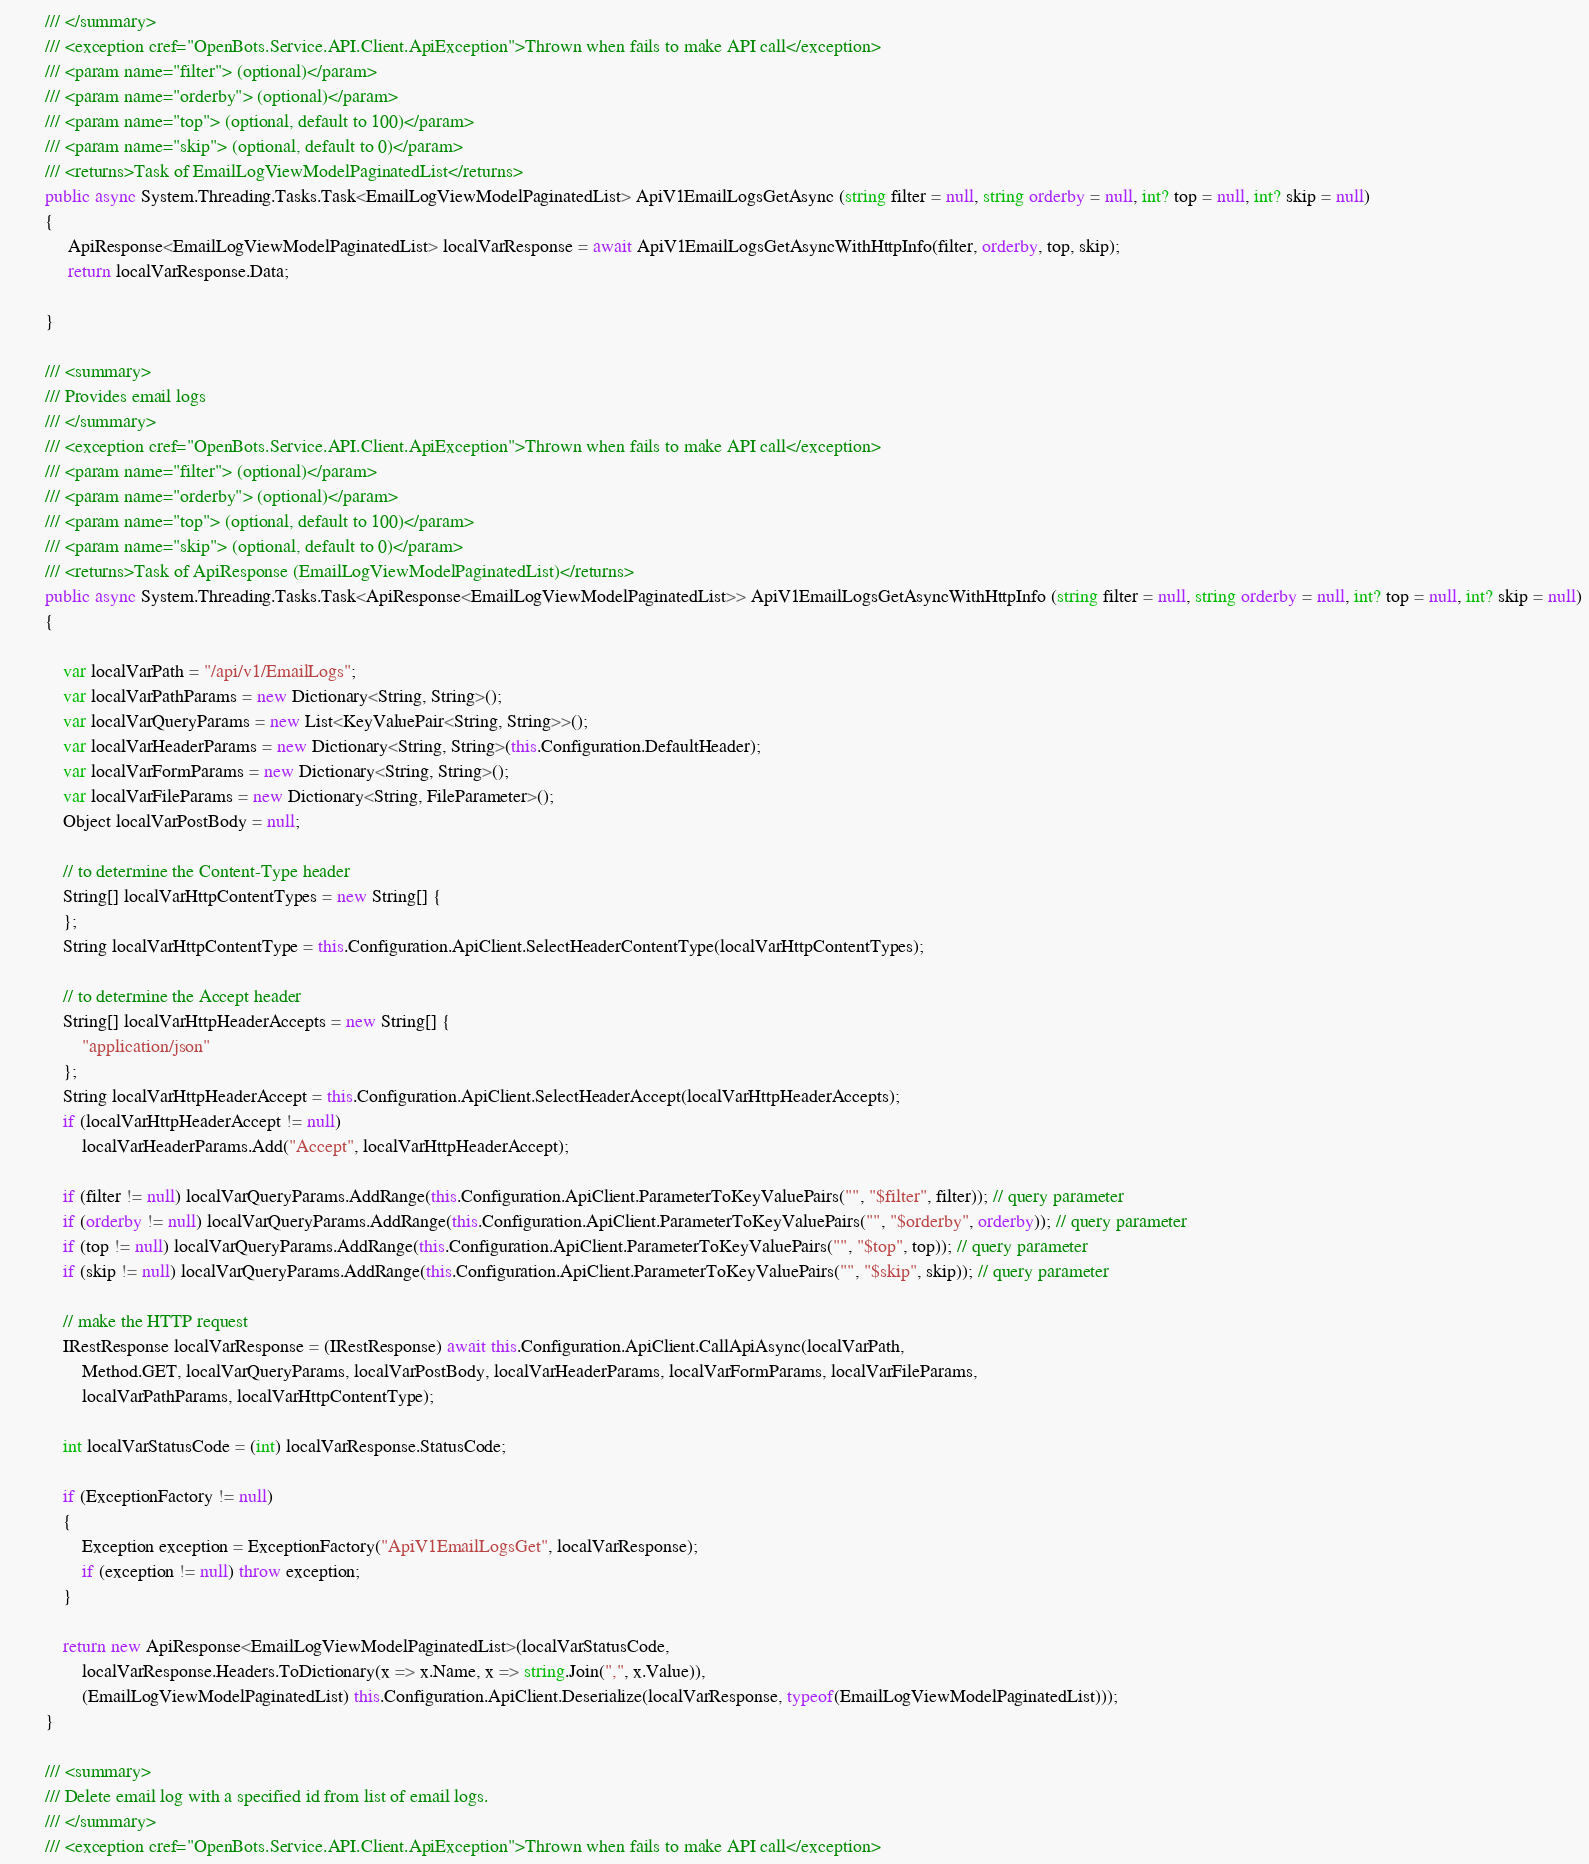<code> <loc_0><loc_0><loc_500><loc_500><_C#_>        /// </summary>
        /// <exception cref="OpenBots.Service.API.Client.ApiException">Thrown when fails to make API call</exception>
        /// <param name="filter"> (optional)</param>
        /// <param name="orderby"> (optional)</param>
        /// <param name="top"> (optional, default to 100)</param>
        /// <param name="skip"> (optional, default to 0)</param>
        /// <returns>Task of EmailLogViewModelPaginatedList</returns>
        public async System.Threading.Tasks.Task<EmailLogViewModelPaginatedList> ApiV1EmailLogsGetAsync (string filter = null, string orderby = null, int? top = null, int? skip = null)
        {
             ApiResponse<EmailLogViewModelPaginatedList> localVarResponse = await ApiV1EmailLogsGetAsyncWithHttpInfo(filter, orderby, top, skip);
             return localVarResponse.Data;

        }

        /// <summary>
        /// Provides email logs 
        /// </summary>
        /// <exception cref="OpenBots.Service.API.Client.ApiException">Thrown when fails to make API call</exception>
        /// <param name="filter"> (optional)</param>
        /// <param name="orderby"> (optional)</param>
        /// <param name="top"> (optional, default to 100)</param>
        /// <param name="skip"> (optional, default to 0)</param>
        /// <returns>Task of ApiResponse (EmailLogViewModelPaginatedList)</returns>
        public async System.Threading.Tasks.Task<ApiResponse<EmailLogViewModelPaginatedList>> ApiV1EmailLogsGetAsyncWithHttpInfo (string filter = null, string orderby = null, int? top = null, int? skip = null)
        {

            var localVarPath = "/api/v1/EmailLogs";
            var localVarPathParams = new Dictionary<String, String>();
            var localVarQueryParams = new List<KeyValuePair<String, String>>();
            var localVarHeaderParams = new Dictionary<String, String>(this.Configuration.DefaultHeader);
            var localVarFormParams = new Dictionary<String, String>();
            var localVarFileParams = new Dictionary<String, FileParameter>();
            Object localVarPostBody = null;

            // to determine the Content-Type header
            String[] localVarHttpContentTypes = new String[] {
            };
            String localVarHttpContentType = this.Configuration.ApiClient.SelectHeaderContentType(localVarHttpContentTypes);

            // to determine the Accept header
            String[] localVarHttpHeaderAccepts = new String[] {
                "application/json"
            };
            String localVarHttpHeaderAccept = this.Configuration.ApiClient.SelectHeaderAccept(localVarHttpHeaderAccepts);
            if (localVarHttpHeaderAccept != null)
                localVarHeaderParams.Add("Accept", localVarHttpHeaderAccept);

            if (filter != null) localVarQueryParams.AddRange(this.Configuration.ApiClient.ParameterToKeyValuePairs("", "$filter", filter)); // query parameter
            if (orderby != null) localVarQueryParams.AddRange(this.Configuration.ApiClient.ParameterToKeyValuePairs("", "$orderby", orderby)); // query parameter
            if (top != null) localVarQueryParams.AddRange(this.Configuration.ApiClient.ParameterToKeyValuePairs("", "$top", top)); // query parameter
            if (skip != null) localVarQueryParams.AddRange(this.Configuration.ApiClient.ParameterToKeyValuePairs("", "$skip", skip)); // query parameter

            // make the HTTP request
            IRestResponse localVarResponse = (IRestResponse) await this.Configuration.ApiClient.CallApiAsync(localVarPath,
                Method.GET, localVarQueryParams, localVarPostBody, localVarHeaderParams, localVarFormParams, localVarFileParams,
                localVarPathParams, localVarHttpContentType);

            int localVarStatusCode = (int) localVarResponse.StatusCode;

            if (ExceptionFactory != null)
            {
                Exception exception = ExceptionFactory("ApiV1EmailLogsGet", localVarResponse);
                if (exception != null) throw exception;
            }

            return new ApiResponse<EmailLogViewModelPaginatedList>(localVarStatusCode,
                localVarResponse.Headers.ToDictionary(x => x.Name, x => string.Join(",", x.Value)),
                (EmailLogViewModelPaginatedList) this.Configuration.ApiClient.Deserialize(localVarResponse, typeof(EmailLogViewModelPaginatedList)));
        }

        /// <summary>
        /// Delete email log with a specified id from list of email logs. 
        /// </summary>
        /// <exception cref="OpenBots.Service.API.Client.ApiException">Thrown when fails to make API call</exception></code> 